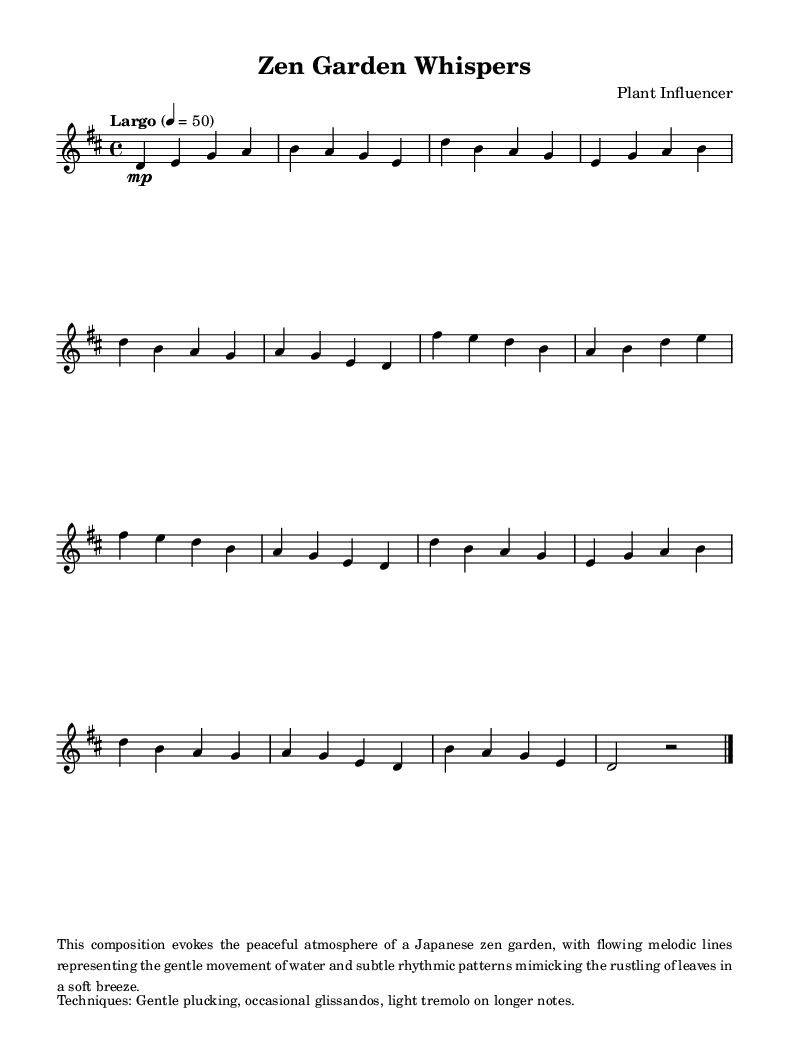What is the key signature of this music? The key signature is indicated by the number of sharps or flats at the beginning of the staff. In this case, there is an 'F#' and 'C#', which indicates that the key signature corresponds to D major.
Answer: D major What is the time signature of this music? The time signature is displayed at the beginning of the piece and is represented by a fraction form. Here, it reads '4/4', indicating that there are four beats in each measure and the quarter note gets one beat.
Answer: 4/4 What is the tempo marking? The tempo marking is found at the beginning of the score after the time signature and specifies the pace of the piece. Here, it is stated as 'Largo', indicating a slow and broad tempo.
Answer: Largo How many different sections are there in the composition? By analyzing the layout of the score, we can see that there are distinct sections labeled as Intro, A, B, A', and Outro. This shows that the piece contains five sections in total.
Answer: Five Which musical technique is highlighted in this composition? The composition notes techniques used in performance. The descriptions indicate that the primary technique in this piece is 'Gentle plucking' as one of the emphasized techniques which contributes to the tranquil atmosphere.
Answer: Gentle plucking How many measures are in section A? Section A consists of four lines where each line contains four beats. Thus, there are 4 measures in total throughout the A section.
Answer: Four What atmosphere does this composition evoke? The music sheet provides a description in the markup section stating that it evokes the peaceful atmosphere of a Japanese zen garden. This context aids in understanding the intention behind the composition.
Answer: Peaceful atmosphere 